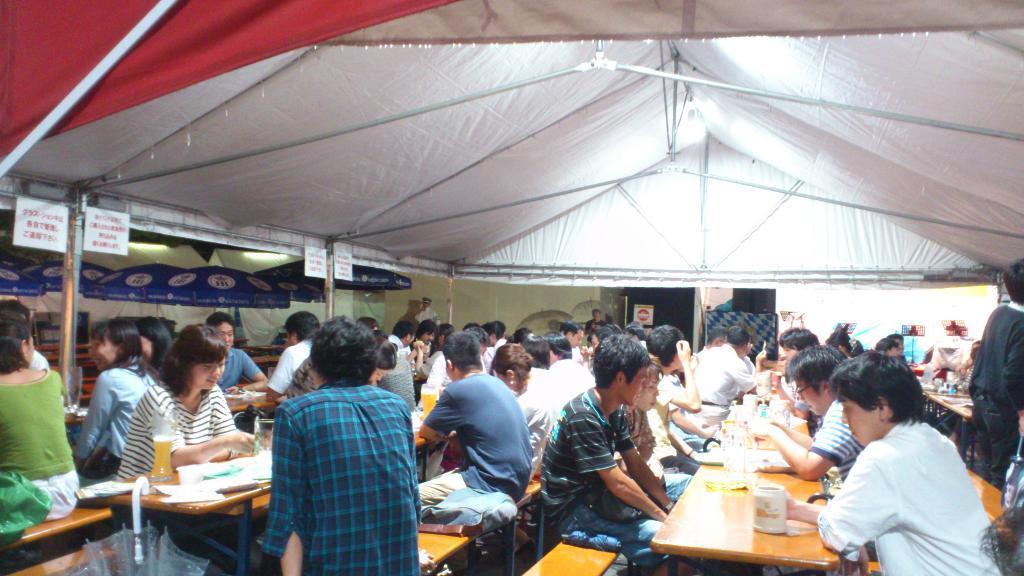Could you give a brief overview of what you see in this image? here we can see a group of people are sitting on the chair, and in front her is the table and some objects on it, and at above here is the light and here is the umbrella. 